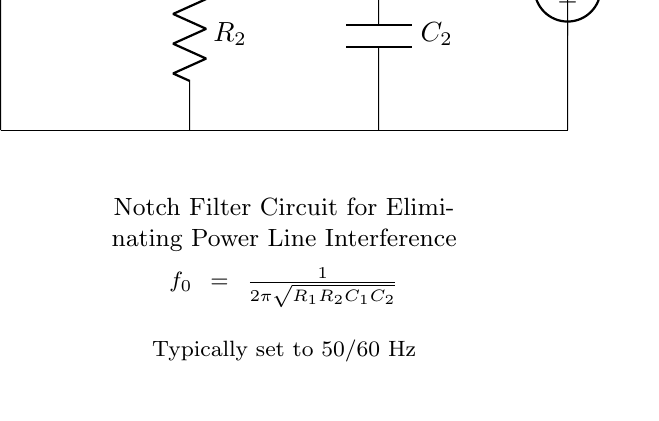What is the type of filter circuit shown? The circuit is a notch filter, which is designed to attenuate a specific frequency while allowing others to pass through. It utilizes resistors and capacitors to achieve this effect.
Answer: Notch filter What is the role of R1 in this circuit? Resistor R1 is part of the notch filter that helps determine the frequency of attenuation. It works in combination with R2 and the capacitors to create the desired filter characteristics.
Answer: Frequency determination What is the typical frequency set for this notch filter? The equation provided in the circuit indicates that the typical frequency is based on the components used, and common practice sets this frequency for 50 or 60 Hz.
Answer: 50/60 Hz Which components are used in this notch filter circuit? The circuit consists of resistors R1 and R2, and capacitors C1 and C2. These components work together to create the filter characteristics of the circuit.
Answer: R1, R2, C1, C2 What is the output voltage derived from? The output voltage Vout is taken from the junctions of the resistor and capacitor in this circuit configuration, representing the filtered signal.
Answer: Filtered signal How is the cutoff frequency calculated? The cutoff frequency is calculated using the provided formula, which involves the product of the resistors and capacitors in the circuit, clearly indicating how they interact to set the notch frequency.
Answer: 1/(2π√(R1R2C1C2)) 